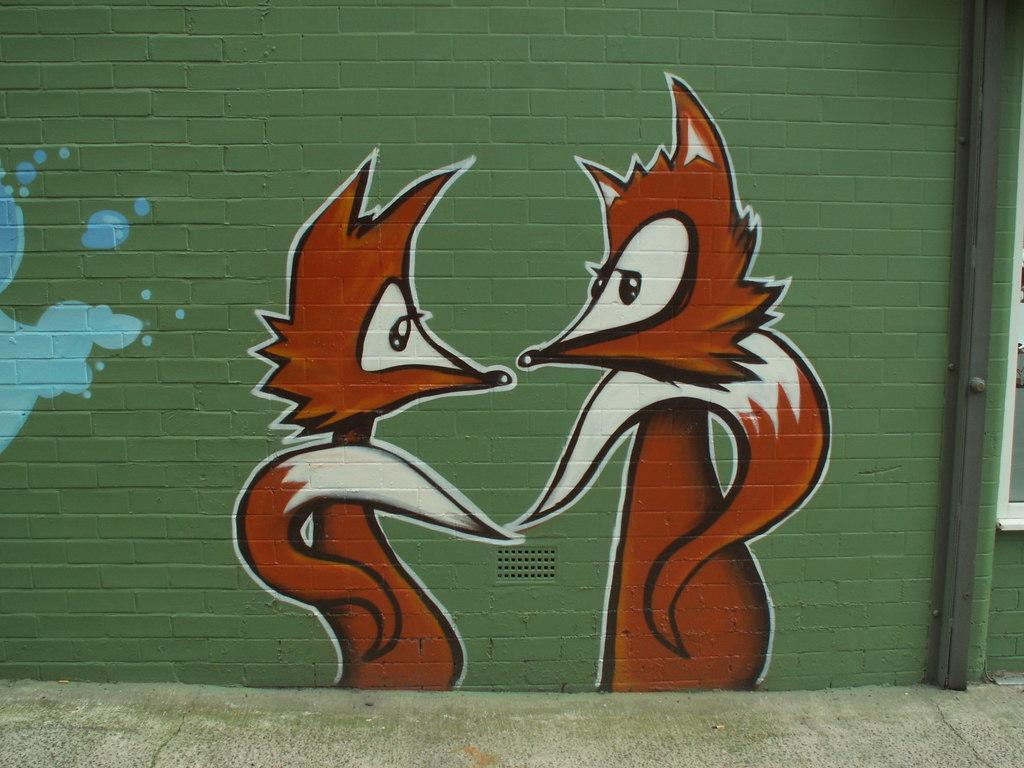Please provide a concise description of this image. In this image I can see wall paintings on a wall and a window. This image is taken may be during a day. 